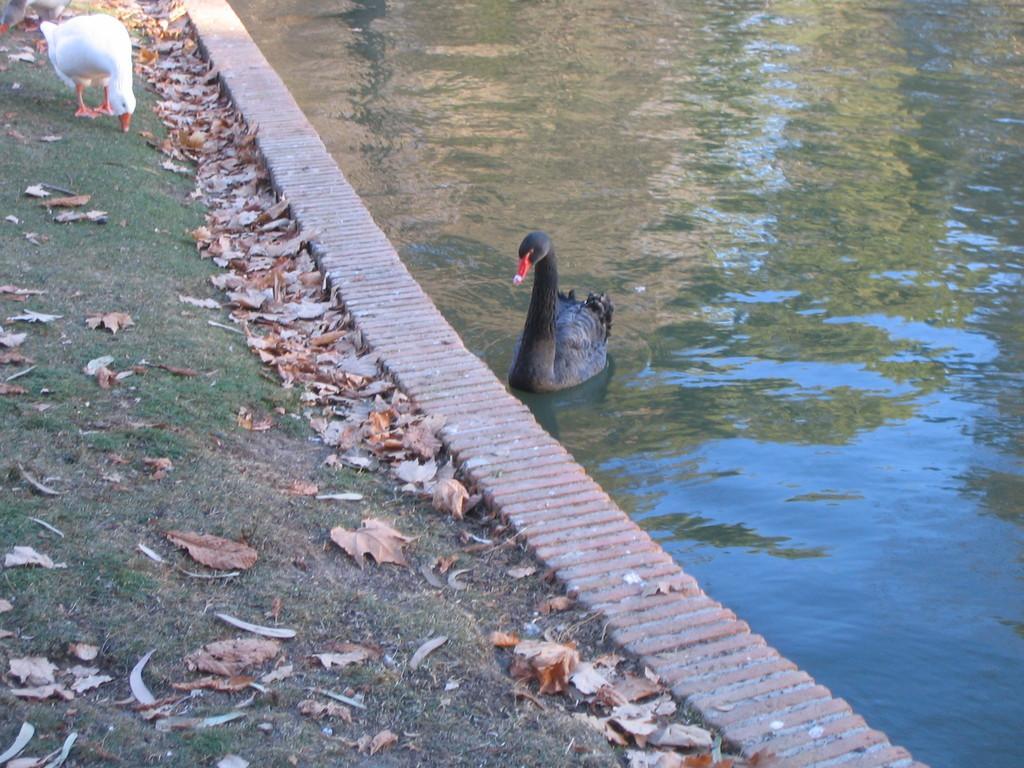In one or two sentences, can you explain what this image depicts? In this image we can see a bird in the water. We can see the reflection of trees and the sky on the water surface. There are few birds at the top left corner of the image. There is a grassy land in the image. There are many dry leaves on the ground. 